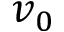<formula> <loc_0><loc_0><loc_500><loc_500>v _ { 0 }</formula> 